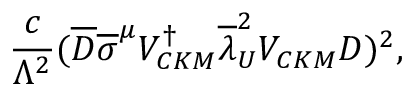<formula> <loc_0><loc_0><loc_500><loc_500>{ \frac { c } { \Lambda ^ { 2 } } } ( \overline { D } { \overline { \sigma } } ^ { \mu } V _ { C K M } ^ { \dagger } { \overline { \lambda } _ { U } ^ { 2 } } V _ { C K M } D ) ^ { 2 } ,</formula> 